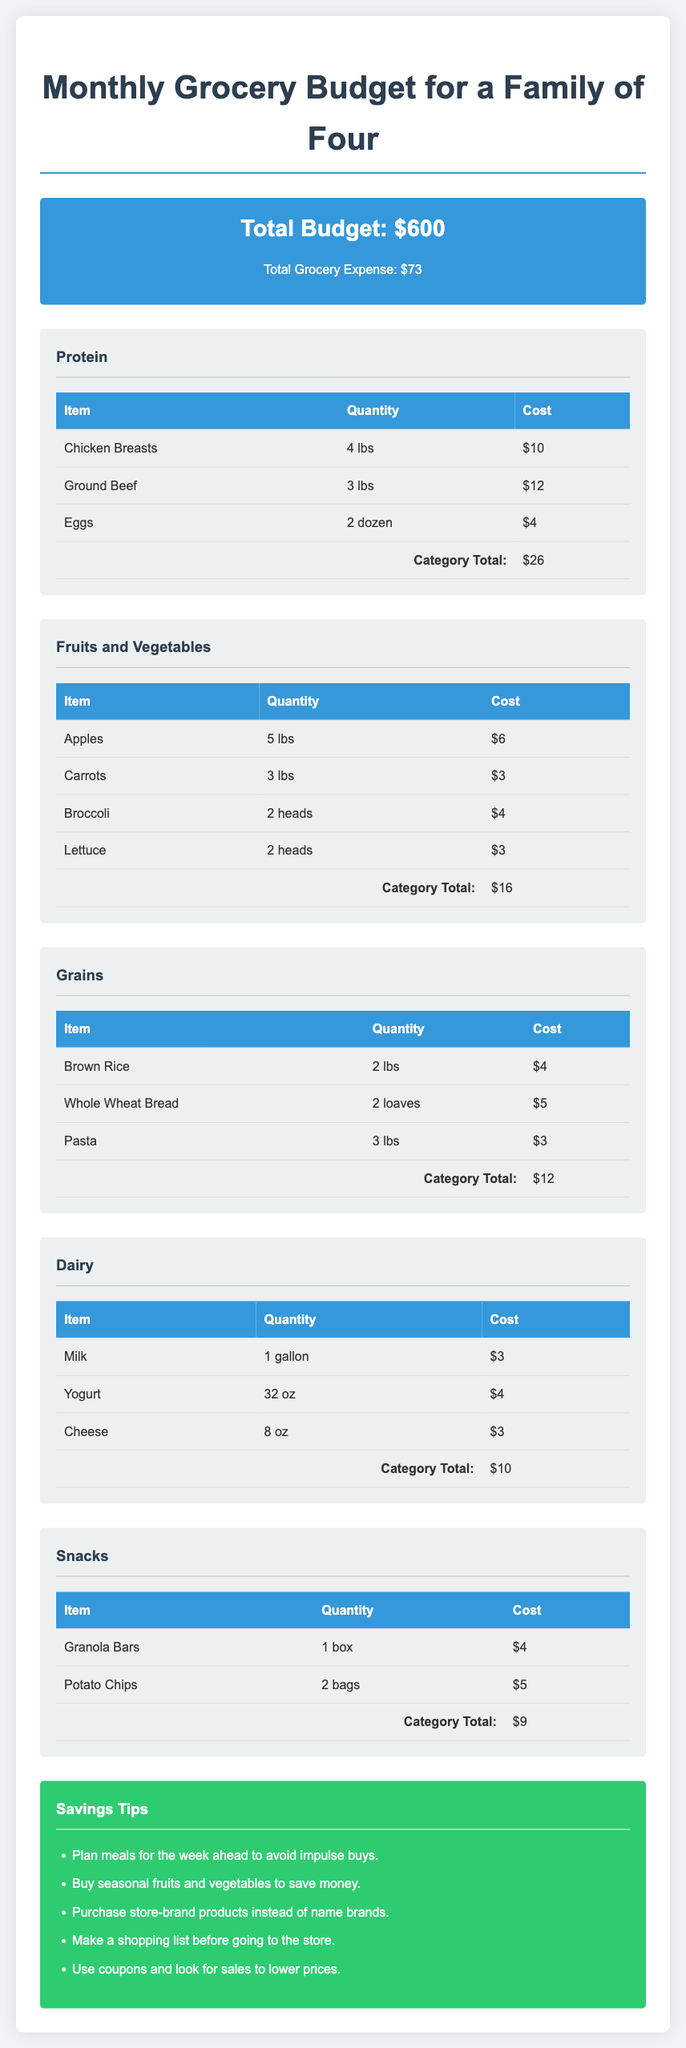What is the total budget for groceries? The total budget is displayed prominently at the top of the document, which is $600.
Answer: $600 What is the total grocery expense? The total grocery expense is shown in the budget summary, which is $73.
Answer: $73 How much did the family spend on protein? The category total for protein is calculated at the bottom of the protein section, which is $26.
Answer: $26 How many pounds of ground beef were purchased? The quantity of ground beef is listed in the protein category, which is 3 lbs.
Answer: 3 lbs Which item is the cheapest in the fruits and vegetables category? The costs for each item are listed, and the cheapest item is identified as carrots at $3.
Answer: $3 What is one of the savings tips provided? Several savings tips are included in a dedicated section, one example is planning meals for the week ahead.
Answer: Plan meals for the week ahead What is the total cost for dairy products? The total cost for dairy is given at the end of the dairy section, which is $10.
Answer: $10 How many pounds of apples were bought? The quantity of apples is specified in the fruits and vegetables category, which is 5 lbs.
Answer: 5 lbs What is the total cost for snacks? The total for snacks can be found at the end of the snacks section, which is $9.
Answer: $9 